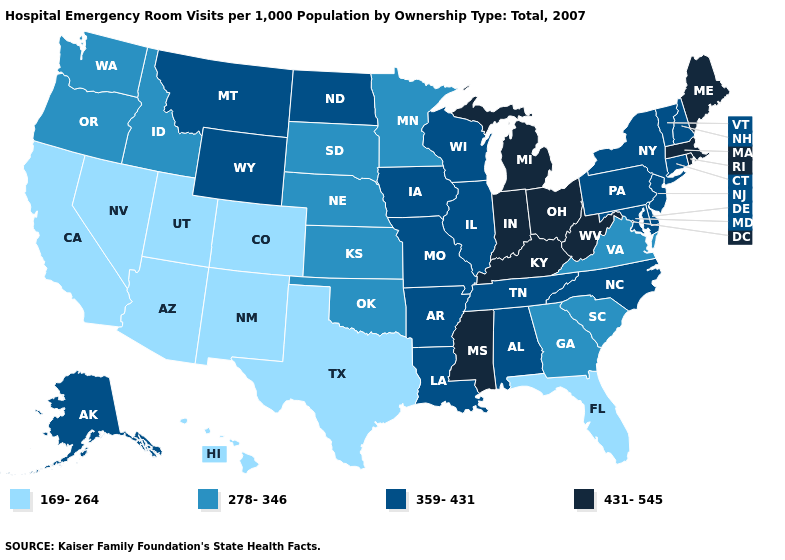What is the value of North Dakota?
Concise answer only. 359-431. What is the lowest value in the USA?
Give a very brief answer. 169-264. What is the lowest value in the South?
Keep it brief. 169-264. Is the legend a continuous bar?
Give a very brief answer. No. Name the states that have a value in the range 431-545?
Answer briefly. Indiana, Kentucky, Maine, Massachusetts, Michigan, Mississippi, Ohio, Rhode Island, West Virginia. What is the value of Arizona?
Answer briefly. 169-264. What is the highest value in the South ?
Be succinct. 431-545. Name the states that have a value in the range 431-545?
Be succinct. Indiana, Kentucky, Maine, Massachusetts, Michigan, Mississippi, Ohio, Rhode Island, West Virginia. What is the value of Kentucky?
Write a very short answer. 431-545. Does the map have missing data?
Quick response, please. No. Does California have the same value as North Carolina?
Concise answer only. No. Which states have the lowest value in the South?
Be succinct. Florida, Texas. What is the value of Massachusetts?
Short answer required. 431-545. Name the states that have a value in the range 278-346?
Quick response, please. Georgia, Idaho, Kansas, Minnesota, Nebraska, Oklahoma, Oregon, South Carolina, South Dakota, Virginia, Washington. Name the states that have a value in the range 359-431?
Be succinct. Alabama, Alaska, Arkansas, Connecticut, Delaware, Illinois, Iowa, Louisiana, Maryland, Missouri, Montana, New Hampshire, New Jersey, New York, North Carolina, North Dakota, Pennsylvania, Tennessee, Vermont, Wisconsin, Wyoming. 